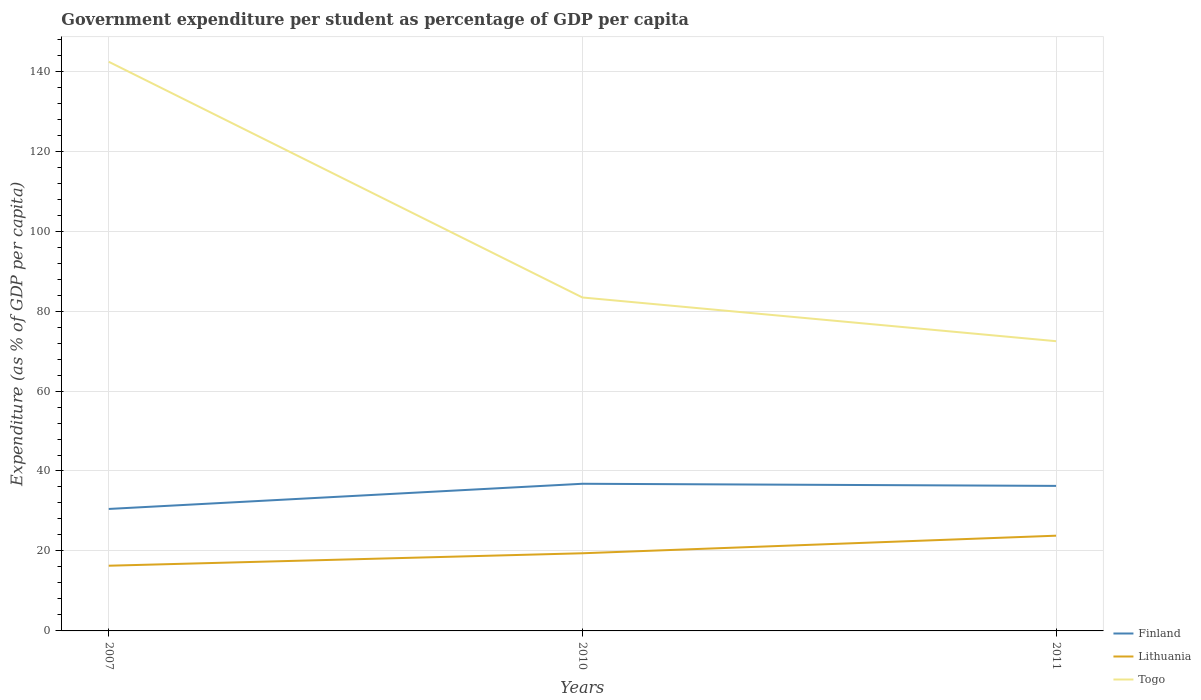How many different coloured lines are there?
Give a very brief answer. 3. Does the line corresponding to Togo intersect with the line corresponding to Finland?
Ensure brevity in your answer.  No. Is the number of lines equal to the number of legend labels?
Your response must be concise. Yes. Across all years, what is the maximum percentage of expenditure per student in Finland?
Offer a terse response. 30.51. What is the total percentage of expenditure per student in Finland in the graph?
Provide a short and direct response. -5.77. What is the difference between the highest and the second highest percentage of expenditure per student in Finland?
Ensure brevity in your answer.  6.3. How many lines are there?
Provide a succinct answer. 3. How many years are there in the graph?
Give a very brief answer. 3. What is the difference between two consecutive major ticks on the Y-axis?
Offer a terse response. 20. How many legend labels are there?
Your response must be concise. 3. What is the title of the graph?
Give a very brief answer. Government expenditure per student as percentage of GDP per capita. What is the label or title of the Y-axis?
Offer a very short reply. Expenditure (as % of GDP per capita). What is the Expenditure (as % of GDP per capita) in Finland in 2007?
Your answer should be compact. 30.51. What is the Expenditure (as % of GDP per capita) in Lithuania in 2007?
Give a very brief answer. 16.31. What is the Expenditure (as % of GDP per capita) of Togo in 2007?
Offer a terse response. 142.35. What is the Expenditure (as % of GDP per capita) in Finland in 2010?
Keep it short and to the point. 36.8. What is the Expenditure (as % of GDP per capita) in Lithuania in 2010?
Your response must be concise. 19.42. What is the Expenditure (as % of GDP per capita) in Togo in 2010?
Ensure brevity in your answer.  83.4. What is the Expenditure (as % of GDP per capita) in Finland in 2011?
Make the answer very short. 36.27. What is the Expenditure (as % of GDP per capita) of Lithuania in 2011?
Your answer should be very brief. 23.82. What is the Expenditure (as % of GDP per capita) of Togo in 2011?
Provide a short and direct response. 72.47. Across all years, what is the maximum Expenditure (as % of GDP per capita) of Finland?
Make the answer very short. 36.8. Across all years, what is the maximum Expenditure (as % of GDP per capita) of Lithuania?
Keep it short and to the point. 23.82. Across all years, what is the maximum Expenditure (as % of GDP per capita) in Togo?
Your answer should be very brief. 142.35. Across all years, what is the minimum Expenditure (as % of GDP per capita) of Finland?
Ensure brevity in your answer.  30.51. Across all years, what is the minimum Expenditure (as % of GDP per capita) of Lithuania?
Provide a succinct answer. 16.31. Across all years, what is the minimum Expenditure (as % of GDP per capita) in Togo?
Your answer should be compact. 72.47. What is the total Expenditure (as % of GDP per capita) of Finland in the graph?
Offer a very short reply. 103.58. What is the total Expenditure (as % of GDP per capita) in Lithuania in the graph?
Your answer should be compact. 59.55. What is the total Expenditure (as % of GDP per capita) in Togo in the graph?
Your answer should be compact. 298.21. What is the difference between the Expenditure (as % of GDP per capita) in Finland in 2007 and that in 2010?
Ensure brevity in your answer.  -6.3. What is the difference between the Expenditure (as % of GDP per capita) in Lithuania in 2007 and that in 2010?
Your answer should be compact. -3.12. What is the difference between the Expenditure (as % of GDP per capita) of Togo in 2007 and that in 2010?
Offer a terse response. 58.95. What is the difference between the Expenditure (as % of GDP per capita) in Finland in 2007 and that in 2011?
Ensure brevity in your answer.  -5.77. What is the difference between the Expenditure (as % of GDP per capita) of Lithuania in 2007 and that in 2011?
Keep it short and to the point. -7.51. What is the difference between the Expenditure (as % of GDP per capita) in Togo in 2007 and that in 2011?
Give a very brief answer. 69.88. What is the difference between the Expenditure (as % of GDP per capita) in Finland in 2010 and that in 2011?
Ensure brevity in your answer.  0.53. What is the difference between the Expenditure (as % of GDP per capita) in Lithuania in 2010 and that in 2011?
Give a very brief answer. -4.4. What is the difference between the Expenditure (as % of GDP per capita) of Togo in 2010 and that in 2011?
Keep it short and to the point. 10.93. What is the difference between the Expenditure (as % of GDP per capita) of Finland in 2007 and the Expenditure (as % of GDP per capita) of Lithuania in 2010?
Give a very brief answer. 11.08. What is the difference between the Expenditure (as % of GDP per capita) of Finland in 2007 and the Expenditure (as % of GDP per capita) of Togo in 2010?
Your response must be concise. -52.89. What is the difference between the Expenditure (as % of GDP per capita) in Lithuania in 2007 and the Expenditure (as % of GDP per capita) in Togo in 2010?
Offer a very short reply. -67.09. What is the difference between the Expenditure (as % of GDP per capita) in Finland in 2007 and the Expenditure (as % of GDP per capita) in Lithuania in 2011?
Offer a very short reply. 6.69. What is the difference between the Expenditure (as % of GDP per capita) in Finland in 2007 and the Expenditure (as % of GDP per capita) in Togo in 2011?
Ensure brevity in your answer.  -41.96. What is the difference between the Expenditure (as % of GDP per capita) of Lithuania in 2007 and the Expenditure (as % of GDP per capita) of Togo in 2011?
Your answer should be compact. -56.16. What is the difference between the Expenditure (as % of GDP per capita) of Finland in 2010 and the Expenditure (as % of GDP per capita) of Lithuania in 2011?
Provide a short and direct response. 12.98. What is the difference between the Expenditure (as % of GDP per capita) in Finland in 2010 and the Expenditure (as % of GDP per capita) in Togo in 2011?
Your answer should be very brief. -35.66. What is the difference between the Expenditure (as % of GDP per capita) in Lithuania in 2010 and the Expenditure (as % of GDP per capita) in Togo in 2011?
Provide a short and direct response. -53.04. What is the average Expenditure (as % of GDP per capita) of Finland per year?
Make the answer very short. 34.53. What is the average Expenditure (as % of GDP per capita) in Lithuania per year?
Provide a short and direct response. 19.85. What is the average Expenditure (as % of GDP per capita) in Togo per year?
Your response must be concise. 99.41. In the year 2007, what is the difference between the Expenditure (as % of GDP per capita) of Finland and Expenditure (as % of GDP per capita) of Lithuania?
Give a very brief answer. 14.2. In the year 2007, what is the difference between the Expenditure (as % of GDP per capita) in Finland and Expenditure (as % of GDP per capita) in Togo?
Give a very brief answer. -111.84. In the year 2007, what is the difference between the Expenditure (as % of GDP per capita) of Lithuania and Expenditure (as % of GDP per capita) of Togo?
Provide a short and direct response. -126.04. In the year 2010, what is the difference between the Expenditure (as % of GDP per capita) of Finland and Expenditure (as % of GDP per capita) of Lithuania?
Keep it short and to the point. 17.38. In the year 2010, what is the difference between the Expenditure (as % of GDP per capita) of Finland and Expenditure (as % of GDP per capita) of Togo?
Your answer should be very brief. -46.59. In the year 2010, what is the difference between the Expenditure (as % of GDP per capita) in Lithuania and Expenditure (as % of GDP per capita) in Togo?
Your answer should be compact. -63.97. In the year 2011, what is the difference between the Expenditure (as % of GDP per capita) in Finland and Expenditure (as % of GDP per capita) in Lithuania?
Your answer should be compact. 12.46. In the year 2011, what is the difference between the Expenditure (as % of GDP per capita) of Finland and Expenditure (as % of GDP per capita) of Togo?
Offer a terse response. -36.19. In the year 2011, what is the difference between the Expenditure (as % of GDP per capita) of Lithuania and Expenditure (as % of GDP per capita) of Togo?
Provide a succinct answer. -48.65. What is the ratio of the Expenditure (as % of GDP per capita) in Finland in 2007 to that in 2010?
Give a very brief answer. 0.83. What is the ratio of the Expenditure (as % of GDP per capita) of Lithuania in 2007 to that in 2010?
Offer a terse response. 0.84. What is the ratio of the Expenditure (as % of GDP per capita) in Togo in 2007 to that in 2010?
Your answer should be compact. 1.71. What is the ratio of the Expenditure (as % of GDP per capita) in Finland in 2007 to that in 2011?
Make the answer very short. 0.84. What is the ratio of the Expenditure (as % of GDP per capita) in Lithuania in 2007 to that in 2011?
Keep it short and to the point. 0.68. What is the ratio of the Expenditure (as % of GDP per capita) in Togo in 2007 to that in 2011?
Your answer should be very brief. 1.96. What is the ratio of the Expenditure (as % of GDP per capita) of Finland in 2010 to that in 2011?
Keep it short and to the point. 1.01. What is the ratio of the Expenditure (as % of GDP per capita) in Lithuania in 2010 to that in 2011?
Make the answer very short. 0.82. What is the ratio of the Expenditure (as % of GDP per capita) of Togo in 2010 to that in 2011?
Keep it short and to the point. 1.15. What is the difference between the highest and the second highest Expenditure (as % of GDP per capita) of Finland?
Give a very brief answer. 0.53. What is the difference between the highest and the second highest Expenditure (as % of GDP per capita) of Lithuania?
Provide a succinct answer. 4.4. What is the difference between the highest and the second highest Expenditure (as % of GDP per capita) in Togo?
Your answer should be very brief. 58.95. What is the difference between the highest and the lowest Expenditure (as % of GDP per capita) of Finland?
Your answer should be very brief. 6.3. What is the difference between the highest and the lowest Expenditure (as % of GDP per capita) of Lithuania?
Your answer should be very brief. 7.51. What is the difference between the highest and the lowest Expenditure (as % of GDP per capita) of Togo?
Your answer should be very brief. 69.88. 